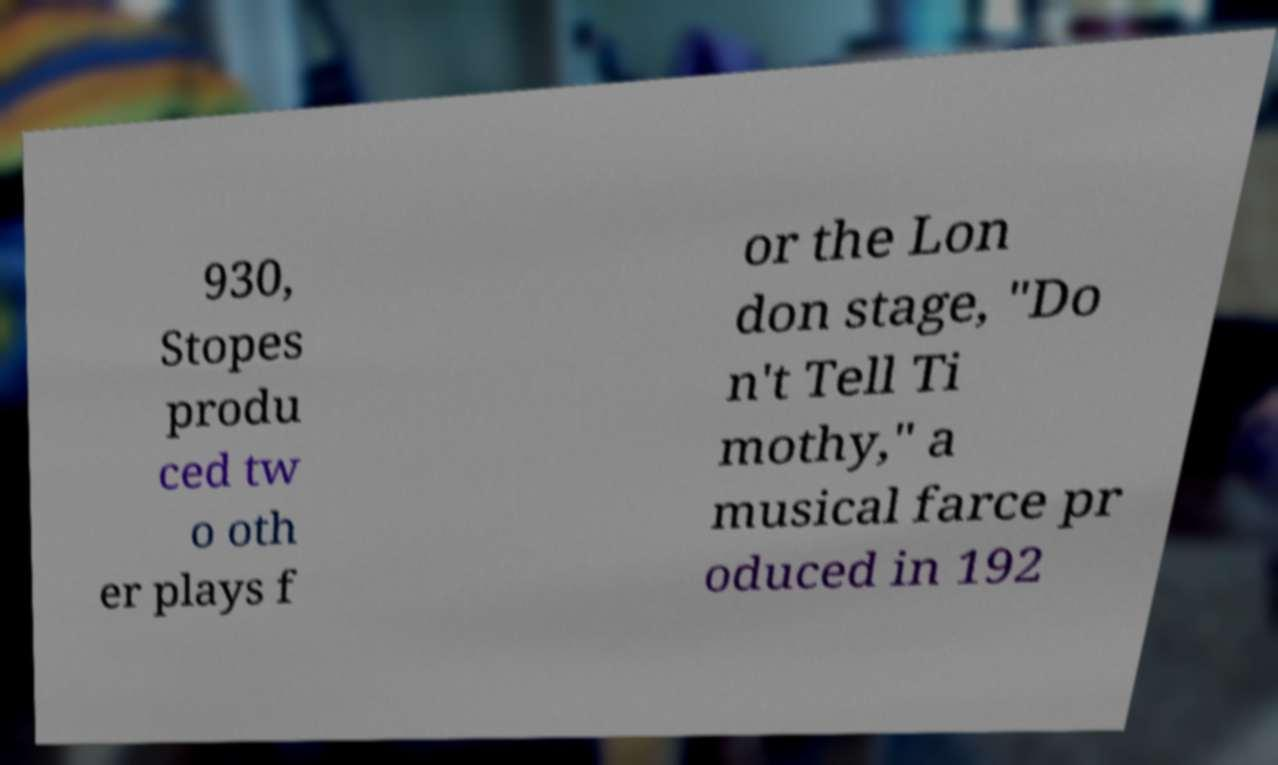What messages or text are displayed in this image? I need them in a readable, typed format. 930, Stopes produ ced tw o oth er plays f or the Lon don stage, "Do n't Tell Ti mothy," a musical farce pr oduced in 192 